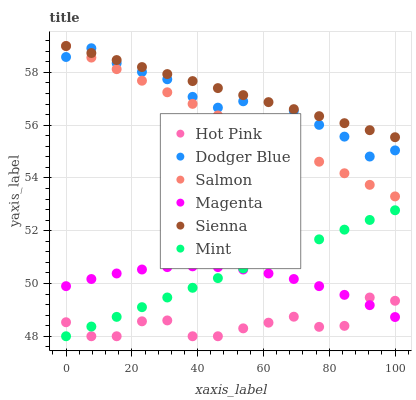Does Hot Pink have the minimum area under the curve?
Answer yes or no. Yes. Does Sienna have the maximum area under the curve?
Answer yes or no. Yes. Does Salmon have the minimum area under the curve?
Answer yes or no. No. Does Salmon have the maximum area under the curve?
Answer yes or no. No. Is Mint the smoothest?
Answer yes or no. Yes. Is Dodger Blue the roughest?
Answer yes or no. Yes. Is Salmon the smoothest?
Answer yes or no. No. Is Salmon the roughest?
Answer yes or no. No. Does Hot Pink have the lowest value?
Answer yes or no. Yes. Does Salmon have the lowest value?
Answer yes or no. No. Does Sienna have the highest value?
Answer yes or no. Yes. Does Dodger Blue have the highest value?
Answer yes or no. No. Is Magenta less than Sienna?
Answer yes or no. Yes. Is Salmon greater than Mint?
Answer yes or no. Yes. Does Sienna intersect Dodger Blue?
Answer yes or no. Yes. Is Sienna less than Dodger Blue?
Answer yes or no. No. Is Sienna greater than Dodger Blue?
Answer yes or no. No. Does Magenta intersect Sienna?
Answer yes or no. No. 